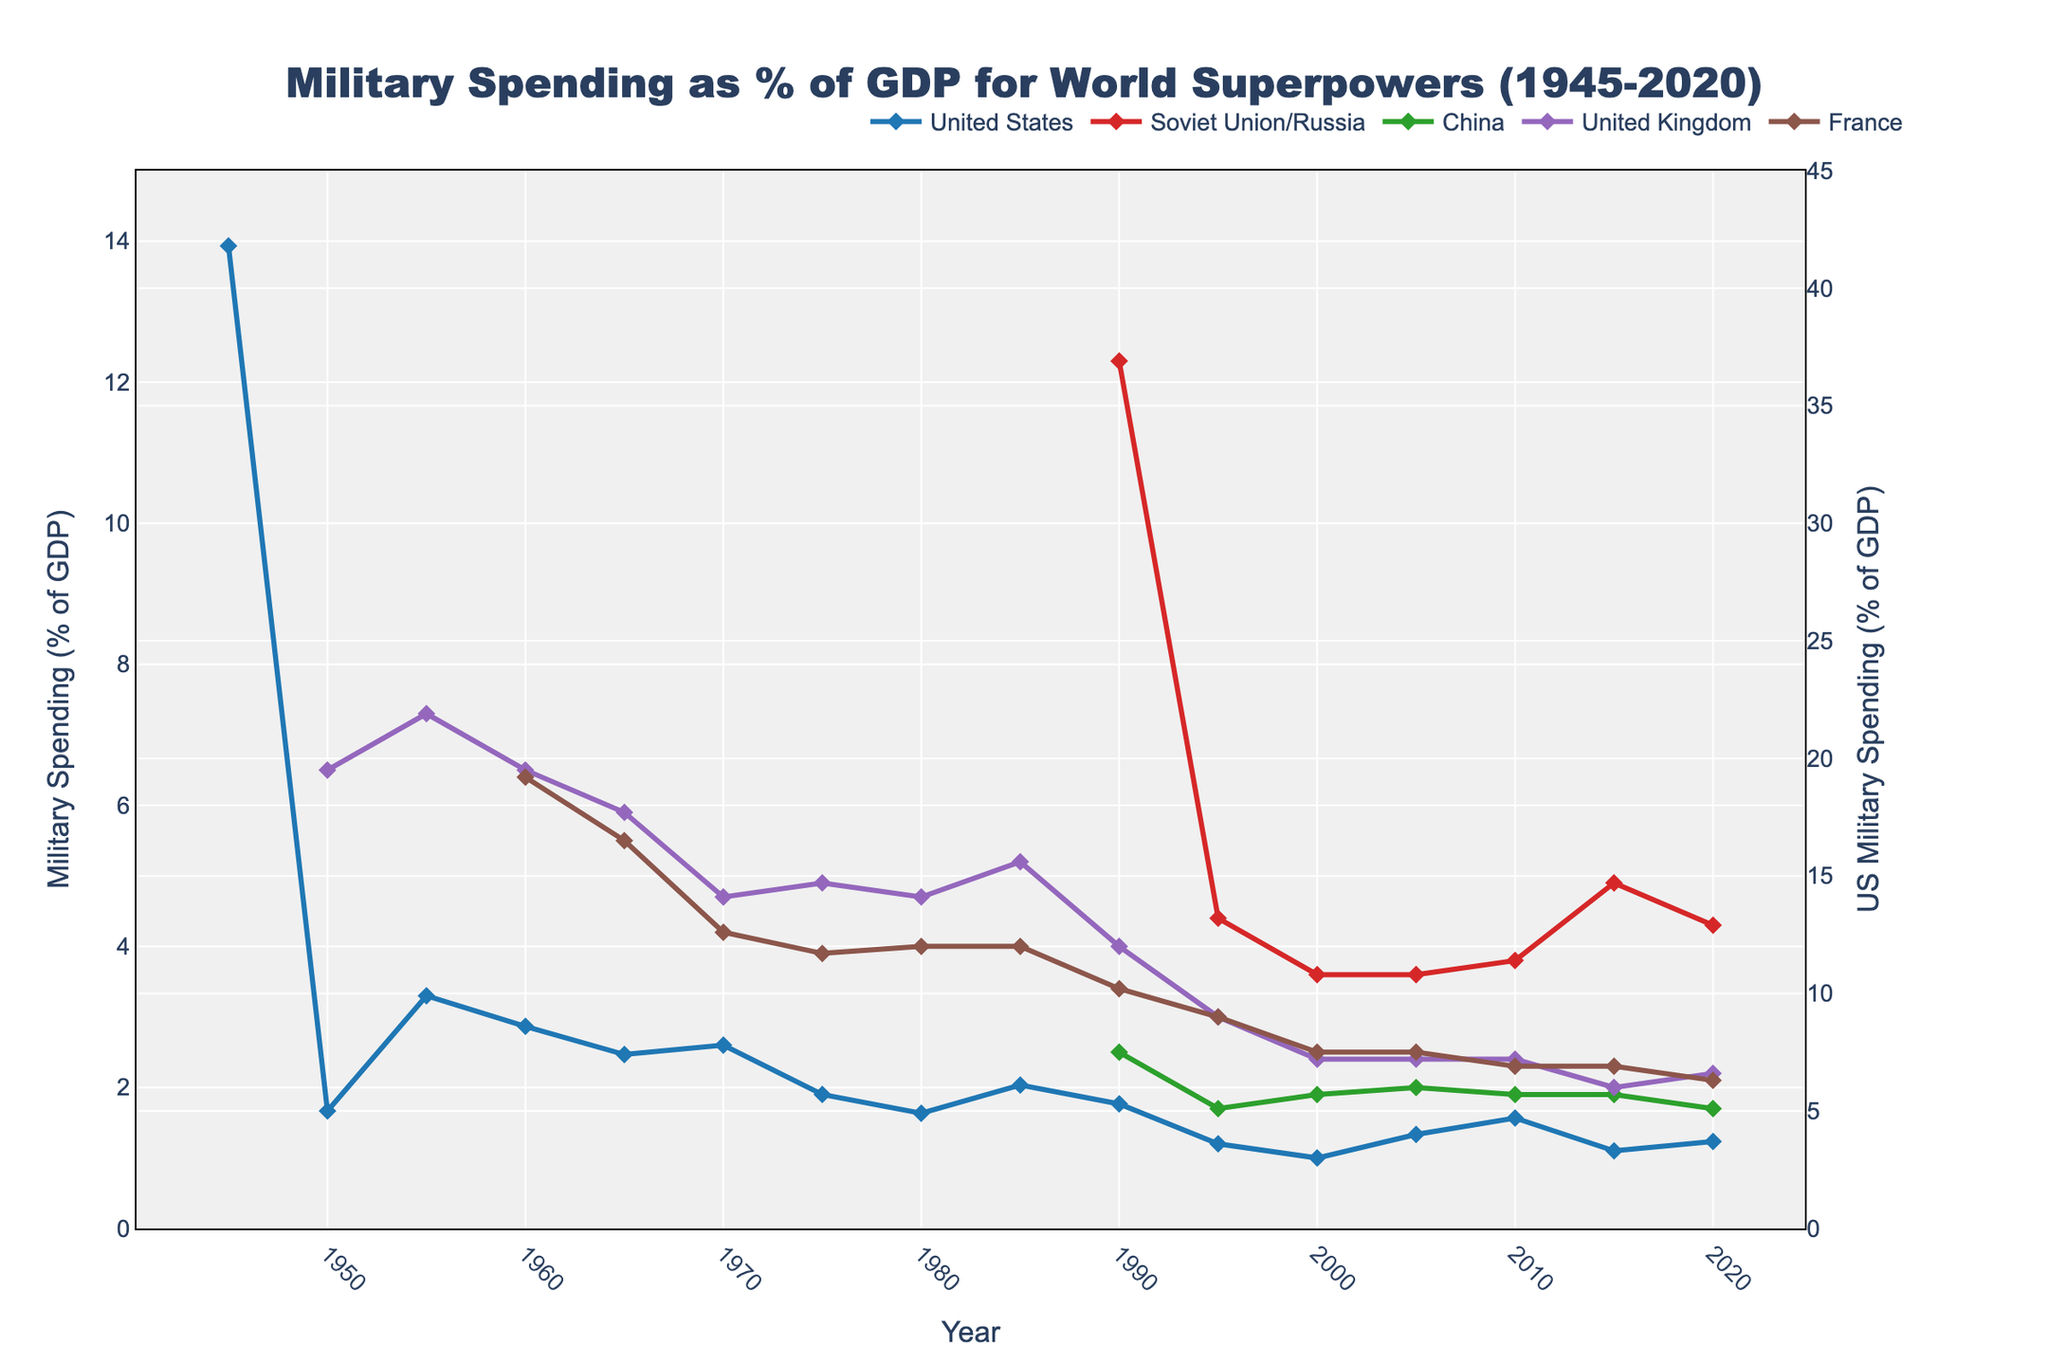What was the highest military spending as a percentage of GDP for any country according to the figure? The highest military spending as a percentage of GDP was for the United States in 1945, reaching 41.8%.
Answer: 41.8% How did the military spending of the United States in 2020 compare to that of China in 2020? In 2020, the United States had military spending of 3.7% of GDP, while China had 1.7% of GDP. Comparing these, the United States had a higher percentage.
Answer: The United States had a higher percentage Which country had the most stable military spending as a percentage of GDP over the years shown? China had relatively stable military spending as a percentage of GDP, consistently around 1.7% to 2.0% in the post-1990 period.
Answer: China In which year did the United States have the lowest military spending as a percentage of GDP, and what was this percentage? The lowest military spending as a percentage of GDP for the United States was in 2000, at 3.0%.
Answer: 2000, 3.0% What was the trend of military spending for France from 1960 to 2020? France's military spending as a percentage of GDP generally decreased from 6.4% in 1960 to 2.1% in 2020.
Answer: Decreasing Compare the military spending of the United Kingdom and France in 1985. Which country spent a higher percentage of its GDP on the military, and by how much? In 1985, the United Kingdom spent 5.2% of its GDP on the military, while France spent 4.0%. The United Kingdom spent 1.2% more.
Answer: The United Kingdom, 1.2% What were the relative changes in military spending as a percentage of GDP for the United States and the Soviet Union/Russia between 1990 and 1995? The United States decreased its military spending from 5.3% in 1990 to 3.6% in 1995 (a reduction of 1.7 percentage points), while the Soviet Union/Russia decreased from 12.3% to 4.4% (a reduction of 7.9 percentage points).
Answer: Both decreased, USSR/Russia by 7.9%, USA by 1.7% How did the military spending of the United States as a percentage of GDP compare during the Cold War (1947-1991) to the post-Cold War period (1992-2020)? During the Cold War, the U.S. military spending fluctuated but was higher overall, often above 5%. After the Cold War, it generally decreased, staying below 5% and only occasionally increasing.
Answer: Higher during the Cold War, lower after 